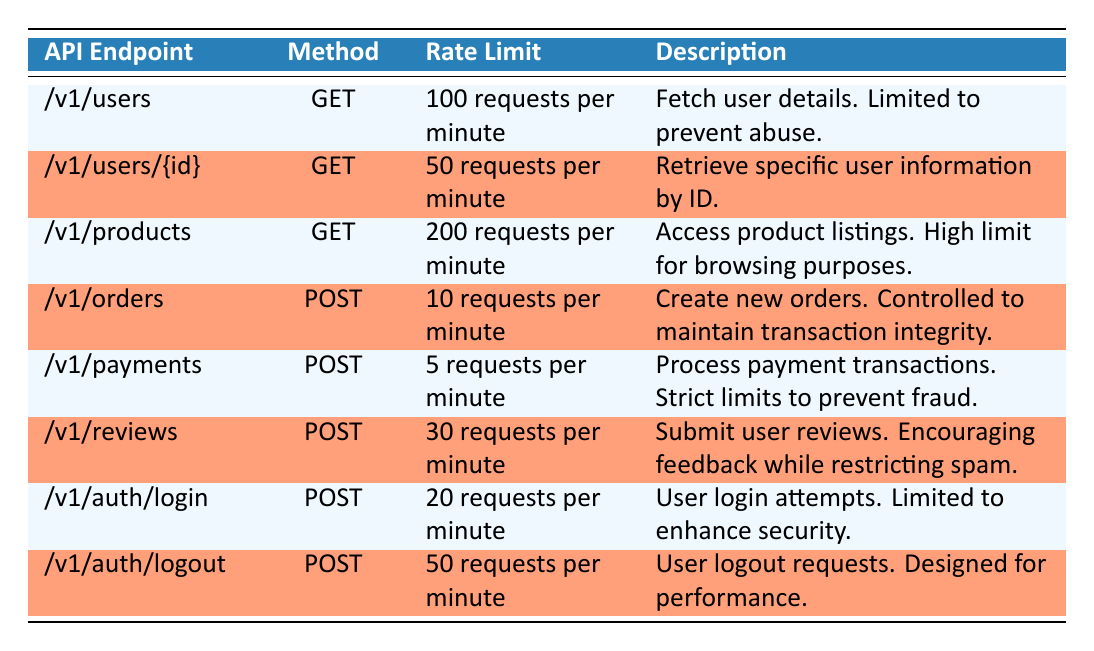What is the rate limit for the endpoint "/v1/users"? The table shows the rate limit for the endpoint "/v1/users" as "100 requests per minute". This can be directly found in the "Rate Limit" column corresponding to that specific endpoint.
Answer: 100 requests per minute How many requests per minute are allowed for posting payments? The table states that the rate limit for the "/v1/payments" endpoint, which is used for posting payments, is "5 requests per minute". This information is present in the corresponding row for the payments endpoint.
Answer: 5 requests per minute Which endpoint has a higher rate limit: "/v1/users" or "/v1/auth/login"? The rate limit for "/v1/users" is "100 requests per minute" and for "/v1/auth/login" it is "20 requests per minute". Since 100 is greater than 20, "/v1/users" has a higher rate limit.
Answer: "/v1/users" Is the rate limit for creating new orders greater than that for submitting user reviews? The rate limit for creating new orders ("/v1/orders") is "10 requests per minute", while for user reviews ("/v1/reviews"), it is "30 requests per minute". Since 10 is not greater than 30, the statement is false.
Answer: No What is the total number of requests per minute allowed for both the "/v1/products" and "/v1/auth/logout" endpoints? The rate limit for "/v1/products" is "200 requests per minute" and for "/v1/auth/logout" is "50 requests per minute". To find the total, sum these values: 200 + 50 = 250.
Answer: 250 requests per minute For all POST requests, what is the average rate limit? The applicable endpoints are "/v1/orders" (10), "/v1/payments" (5), "/v1/reviews" (30), and "/v1/auth/login" (20). First, sum these: 10 + 5 + 30 + 20 = 65. Then, divide by the number of POST requests (4): 65 / 4 = 16.25.
Answer: 16.25 requests per minute Is it true that all GET requests have a higher rate limit than all POST requests? The rate limits for GET requests are: "/v1/users" (100), "/v1/users/{id}" (50), and "/v1/products" (200). The highest rate limit for POST requests is "/v1/reviews" at 30. Since 200 is greater than 30, this statement is true.
Answer: Yes What is the lowest rate limit across all endpoints? By examining the rate limits provided for each endpoint, the lowest rate limit is "5 requests per minute" for the "/v1/payments" endpoint. This can be verified by comparing the values across the table.
Answer: 5 requests per minute 